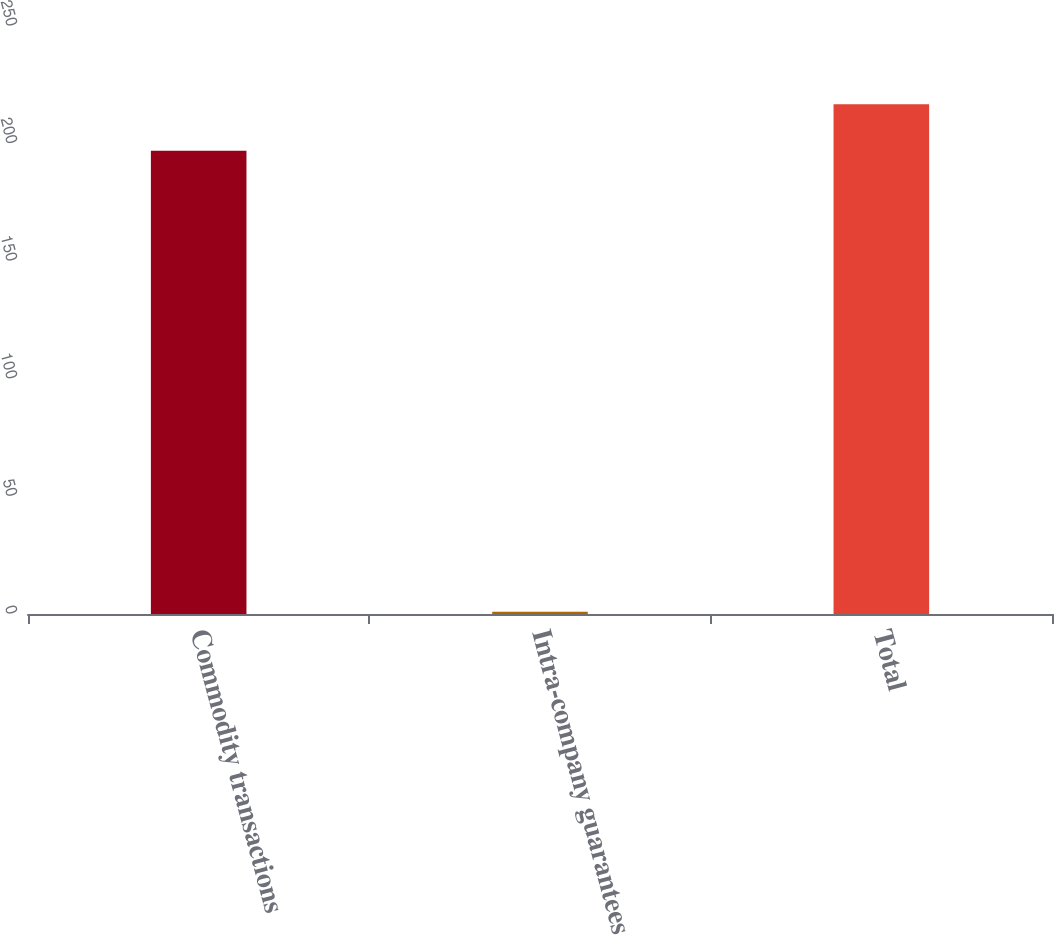Convert chart. <chart><loc_0><loc_0><loc_500><loc_500><bar_chart><fcel>Commodity transactions<fcel>Intra-company guarantees<fcel>Total<nl><fcel>197<fcel>1<fcel>216.7<nl></chart> 